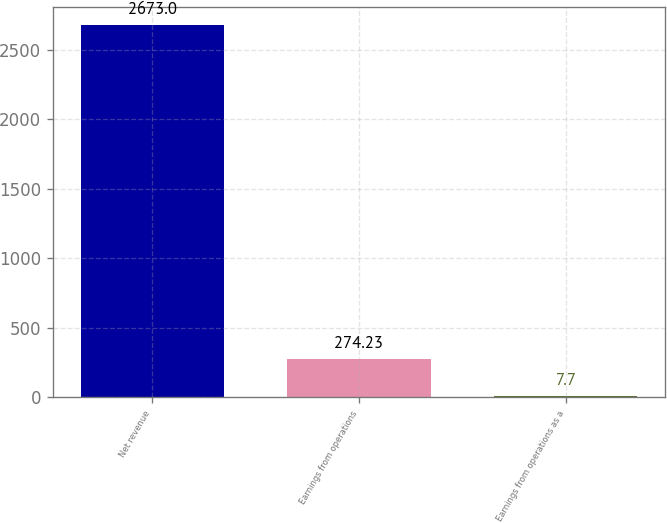Convert chart. <chart><loc_0><loc_0><loc_500><loc_500><bar_chart><fcel>Net revenue<fcel>Earnings from operations<fcel>Earnings from operations as a<nl><fcel>2673<fcel>274.23<fcel>7.7<nl></chart> 